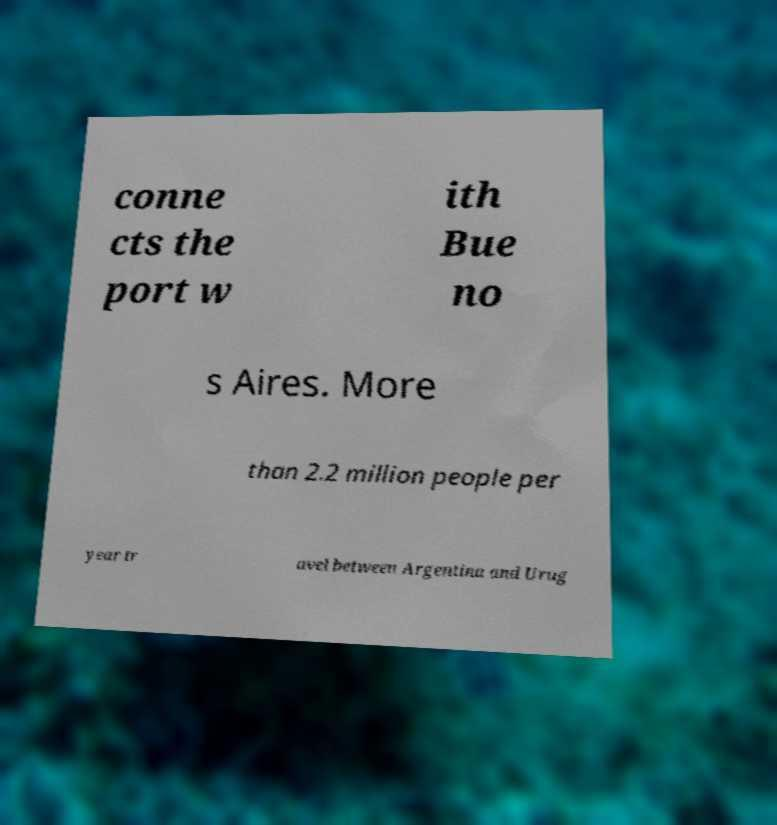Can you read and provide the text displayed in the image?This photo seems to have some interesting text. Can you extract and type it out for me? conne cts the port w ith Bue no s Aires. More than 2.2 million people per year tr avel between Argentina and Urug 